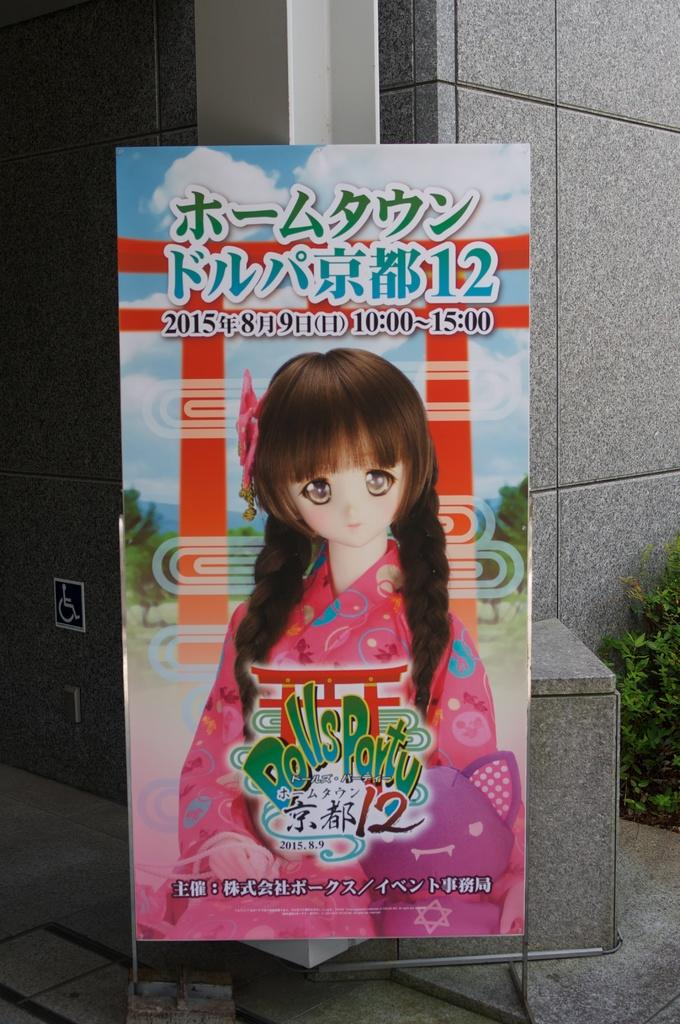What is the main object in the image? There is a board in the image. What is depicted on the board? There is a depiction of a doll on the board. What else can be seen on the board? There is text on the board. What can be seen in the background of the image? There is a wall in the background of the image. What type of vegetation is present in the image? There is a plant on the right side of the image. How many yams are being carried by the cattle in the image? There are no yams or cattle present in the image. What type of ear is visible on the doll in the image? The image does not show the doll's ears, as it only depicts the doll on the board. 